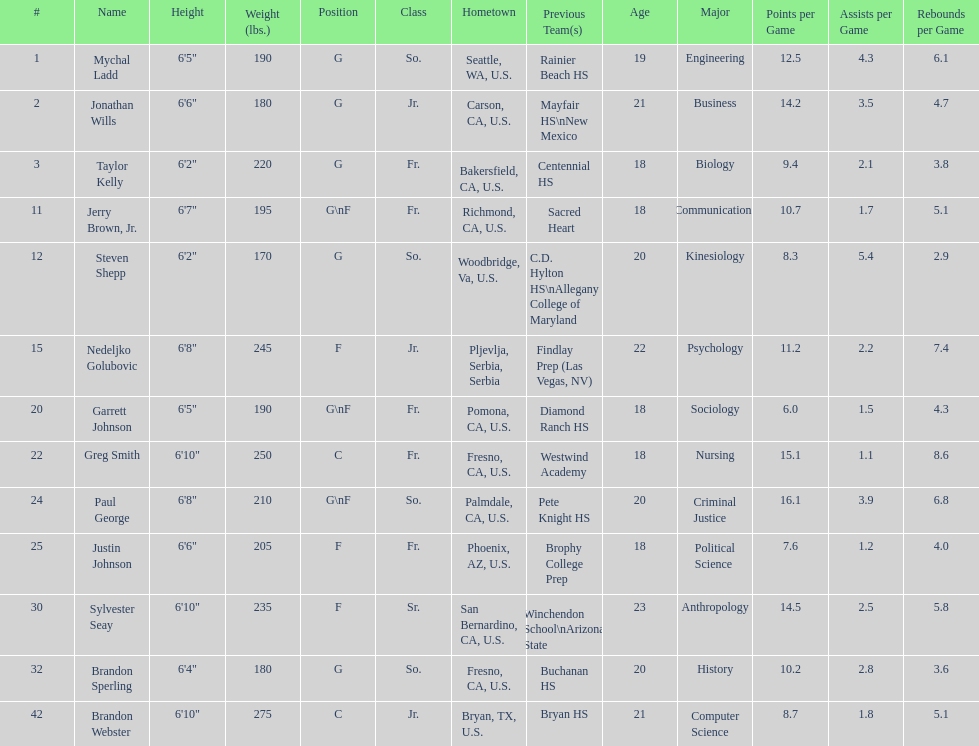Which player who is only a forward (f) is the shortest? Justin Johnson. 